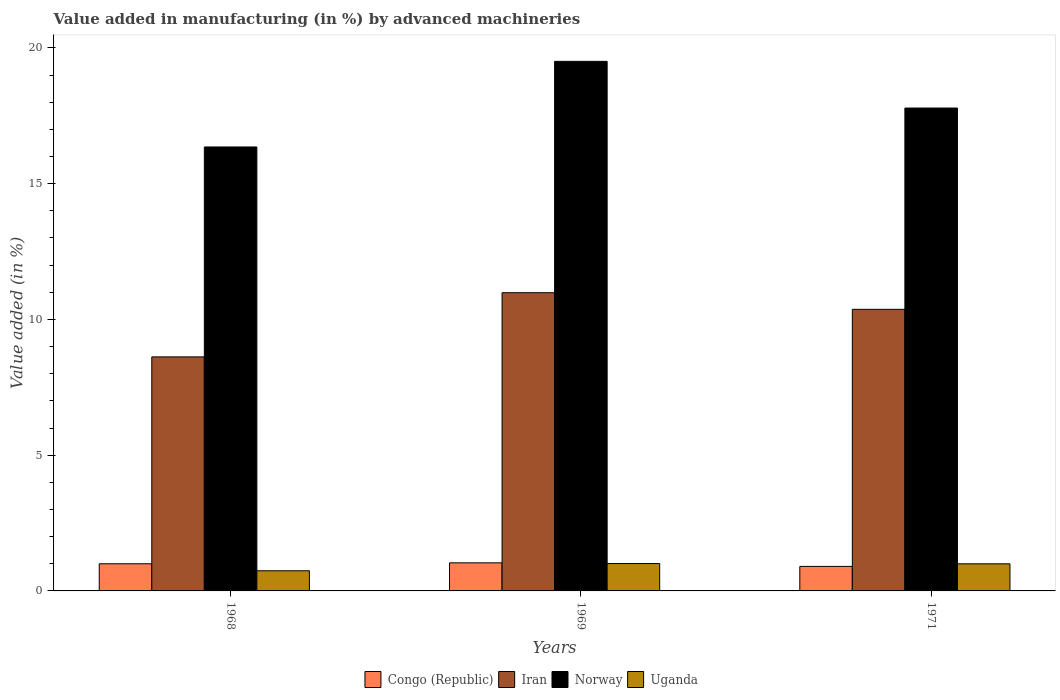Are the number of bars per tick equal to the number of legend labels?
Offer a terse response. Yes. Are the number of bars on each tick of the X-axis equal?
Offer a very short reply. Yes. How many bars are there on the 2nd tick from the left?
Your answer should be compact. 4. How many bars are there on the 2nd tick from the right?
Provide a short and direct response. 4. What is the label of the 2nd group of bars from the left?
Provide a short and direct response. 1969. In how many cases, is the number of bars for a given year not equal to the number of legend labels?
Offer a very short reply. 0. What is the percentage of value added in manufacturing by advanced machineries in Uganda in 1968?
Ensure brevity in your answer.  0.74. Across all years, what is the maximum percentage of value added in manufacturing by advanced machineries in Iran?
Your response must be concise. 10.98. Across all years, what is the minimum percentage of value added in manufacturing by advanced machineries in Norway?
Offer a terse response. 16.35. In which year was the percentage of value added in manufacturing by advanced machineries in Iran maximum?
Give a very brief answer. 1969. In which year was the percentage of value added in manufacturing by advanced machineries in Iran minimum?
Your answer should be very brief. 1968. What is the total percentage of value added in manufacturing by advanced machineries in Iran in the graph?
Keep it short and to the point. 29.97. What is the difference between the percentage of value added in manufacturing by advanced machineries in Uganda in 1968 and that in 1971?
Keep it short and to the point. -0.26. What is the difference between the percentage of value added in manufacturing by advanced machineries in Norway in 1969 and the percentage of value added in manufacturing by advanced machineries in Iran in 1971?
Give a very brief answer. 9.13. What is the average percentage of value added in manufacturing by advanced machineries in Norway per year?
Provide a short and direct response. 17.88. In the year 1968, what is the difference between the percentage of value added in manufacturing by advanced machineries in Uganda and percentage of value added in manufacturing by advanced machineries in Iran?
Offer a terse response. -7.88. In how many years, is the percentage of value added in manufacturing by advanced machineries in Uganda greater than 4 %?
Provide a succinct answer. 0. What is the ratio of the percentage of value added in manufacturing by advanced machineries in Uganda in 1968 to that in 1969?
Your answer should be very brief. 0.74. Is the difference between the percentage of value added in manufacturing by advanced machineries in Uganda in 1968 and 1971 greater than the difference between the percentage of value added in manufacturing by advanced machineries in Iran in 1968 and 1971?
Your response must be concise. Yes. What is the difference between the highest and the second highest percentage of value added in manufacturing by advanced machineries in Norway?
Your answer should be compact. 1.72. What is the difference between the highest and the lowest percentage of value added in manufacturing by advanced machineries in Uganda?
Provide a succinct answer. 0.27. In how many years, is the percentage of value added in manufacturing by advanced machineries in Uganda greater than the average percentage of value added in manufacturing by advanced machineries in Uganda taken over all years?
Keep it short and to the point. 2. Is it the case that in every year, the sum of the percentage of value added in manufacturing by advanced machineries in Norway and percentage of value added in manufacturing by advanced machineries in Congo (Republic) is greater than the sum of percentage of value added in manufacturing by advanced machineries in Uganda and percentage of value added in manufacturing by advanced machineries in Iran?
Make the answer very short. No. What does the 4th bar from the right in 1968 represents?
Make the answer very short. Congo (Republic). How many bars are there?
Give a very brief answer. 12. Are the values on the major ticks of Y-axis written in scientific E-notation?
Give a very brief answer. No. What is the title of the graph?
Offer a terse response. Value added in manufacturing (in %) by advanced machineries. Does "Pakistan" appear as one of the legend labels in the graph?
Your answer should be very brief. No. What is the label or title of the X-axis?
Give a very brief answer. Years. What is the label or title of the Y-axis?
Offer a very short reply. Value added (in %). What is the Value added (in %) of Congo (Republic) in 1968?
Your response must be concise. 1. What is the Value added (in %) in Iran in 1968?
Your answer should be compact. 8.62. What is the Value added (in %) in Norway in 1968?
Provide a short and direct response. 16.35. What is the Value added (in %) in Uganda in 1968?
Your answer should be compact. 0.74. What is the Value added (in %) of Congo (Republic) in 1969?
Your response must be concise. 1.03. What is the Value added (in %) of Iran in 1969?
Make the answer very short. 10.98. What is the Value added (in %) in Norway in 1969?
Your response must be concise. 19.5. What is the Value added (in %) in Uganda in 1969?
Your response must be concise. 1.01. What is the Value added (in %) in Congo (Republic) in 1971?
Provide a succinct answer. 0.9. What is the Value added (in %) in Iran in 1971?
Provide a succinct answer. 10.37. What is the Value added (in %) of Norway in 1971?
Offer a very short reply. 17.79. What is the Value added (in %) of Uganda in 1971?
Provide a short and direct response. 1. Across all years, what is the maximum Value added (in %) of Congo (Republic)?
Make the answer very short. 1.03. Across all years, what is the maximum Value added (in %) in Iran?
Offer a very short reply. 10.98. Across all years, what is the maximum Value added (in %) in Norway?
Offer a terse response. 19.5. Across all years, what is the maximum Value added (in %) in Uganda?
Provide a short and direct response. 1.01. Across all years, what is the minimum Value added (in %) of Congo (Republic)?
Ensure brevity in your answer.  0.9. Across all years, what is the minimum Value added (in %) in Iran?
Make the answer very short. 8.62. Across all years, what is the minimum Value added (in %) in Norway?
Ensure brevity in your answer.  16.35. Across all years, what is the minimum Value added (in %) of Uganda?
Provide a short and direct response. 0.74. What is the total Value added (in %) of Congo (Republic) in the graph?
Keep it short and to the point. 2.94. What is the total Value added (in %) of Iran in the graph?
Your response must be concise. 29.97. What is the total Value added (in %) of Norway in the graph?
Make the answer very short. 53.64. What is the total Value added (in %) of Uganda in the graph?
Provide a short and direct response. 2.75. What is the difference between the Value added (in %) in Congo (Republic) in 1968 and that in 1969?
Your answer should be compact. -0.03. What is the difference between the Value added (in %) of Iran in 1968 and that in 1969?
Your answer should be very brief. -2.36. What is the difference between the Value added (in %) in Norway in 1968 and that in 1969?
Your response must be concise. -3.15. What is the difference between the Value added (in %) of Uganda in 1968 and that in 1969?
Provide a succinct answer. -0.27. What is the difference between the Value added (in %) of Congo (Republic) in 1968 and that in 1971?
Keep it short and to the point. 0.1. What is the difference between the Value added (in %) of Iran in 1968 and that in 1971?
Your answer should be very brief. -1.75. What is the difference between the Value added (in %) of Norway in 1968 and that in 1971?
Your answer should be very brief. -1.43. What is the difference between the Value added (in %) in Uganda in 1968 and that in 1971?
Your answer should be compact. -0.26. What is the difference between the Value added (in %) of Congo (Republic) in 1969 and that in 1971?
Ensure brevity in your answer.  0.13. What is the difference between the Value added (in %) of Iran in 1969 and that in 1971?
Provide a short and direct response. 0.61. What is the difference between the Value added (in %) of Norway in 1969 and that in 1971?
Your answer should be very brief. 1.72. What is the difference between the Value added (in %) of Uganda in 1969 and that in 1971?
Provide a succinct answer. 0.01. What is the difference between the Value added (in %) of Congo (Republic) in 1968 and the Value added (in %) of Iran in 1969?
Provide a short and direct response. -9.98. What is the difference between the Value added (in %) of Congo (Republic) in 1968 and the Value added (in %) of Norway in 1969?
Offer a very short reply. -18.5. What is the difference between the Value added (in %) in Congo (Republic) in 1968 and the Value added (in %) in Uganda in 1969?
Keep it short and to the point. -0.01. What is the difference between the Value added (in %) in Iran in 1968 and the Value added (in %) in Norway in 1969?
Give a very brief answer. -10.88. What is the difference between the Value added (in %) of Iran in 1968 and the Value added (in %) of Uganda in 1969?
Your response must be concise. 7.61. What is the difference between the Value added (in %) in Norway in 1968 and the Value added (in %) in Uganda in 1969?
Provide a short and direct response. 15.34. What is the difference between the Value added (in %) in Congo (Republic) in 1968 and the Value added (in %) in Iran in 1971?
Make the answer very short. -9.37. What is the difference between the Value added (in %) in Congo (Republic) in 1968 and the Value added (in %) in Norway in 1971?
Make the answer very short. -16.79. What is the difference between the Value added (in %) in Congo (Republic) in 1968 and the Value added (in %) in Uganda in 1971?
Provide a succinct answer. 0. What is the difference between the Value added (in %) of Iran in 1968 and the Value added (in %) of Norway in 1971?
Your response must be concise. -9.17. What is the difference between the Value added (in %) in Iran in 1968 and the Value added (in %) in Uganda in 1971?
Make the answer very short. 7.62. What is the difference between the Value added (in %) in Norway in 1968 and the Value added (in %) in Uganda in 1971?
Ensure brevity in your answer.  15.35. What is the difference between the Value added (in %) in Congo (Republic) in 1969 and the Value added (in %) in Iran in 1971?
Ensure brevity in your answer.  -9.34. What is the difference between the Value added (in %) of Congo (Republic) in 1969 and the Value added (in %) of Norway in 1971?
Offer a terse response. -16.75. What is the difference between the Value added (in %) of Congo (Republic) in 1969 and the Value added (in %) of Uganda in 1971?
Keep it short and to the point. 0.04. What is the difference between the Value added (in %) of Iran in 1969 and the Value added (in %) of Norway in 1971?
Offer a terse response. -6.8. What is the difference between the Value added (in %) of Iran in 1969 and the Value added (in %) of Uganda in 1971?
Offer a terse response. 9.98. What is the difference between the Value added (in %) of Norway in 1969 and the Value added (in %) of Uganda in 1971?
Your answer should be very brief. 18.51. What is the average Value added (in %) of Congo (Republic) per year?
Ensure brevity in your answer.  0.98. What is the average Value added (in %) in Iran per year?
Make the answer very short. 9.99. What is the average Value added (in %) of Norway per year?
Keep it short and to the point. 17.88. What is the average Value added (in %) in Uganda per year?
Provide a short and direct response. 0.92. In the year 1968, what is the difference between the Value added (in %) in Congo (Republic) and Value added (in %) in Iran?
Keep it short and to the point. -7.62. In the year 1968, what is the difference between the Value added (in %) in Congo (Republic) and Value added (in %) in Norway?
Make the answer very short. -15.35. In the year 1968, what is the difference between the Value added (in %) in Congo (Republic) and Value added (in %) in Uganda?
Your answer should be compact. 0.26. In the year 1968, what is the difference between the Value added (in %) in Iran and Value added (in %) in Norway?
Give a very brief answer. -7.73. In the year 1968, what is the difference between the Value added (in %) of Iran and Value added (in %) of Uganda?
Offer a terse response. 7.88. In the year 1968, what is the difference between the Value added (in %) of Norway and Value added (in %) of Uganda?
Your answer should be very brief. 15.61. In the year 1969, what is the difference between the Value added (in %) in Congo (Republic) and Value added (in %) in Iran?
Offer a very short reply. -9.95. In the year 1969, what is the difference between the Value added (in %) of Congo (Republic) and Value added (in %) of Norway?
Offer a very short reply. -18.47. In the year 1969, what is the difference between the Value added (in %) of Congo (Republic) and Value added (in %) of Uganda?
Make the answer very short. 0.03. In the year 1969, what is the difference between the Value added (in %) in Iran and Value added (in %) in Norway?
Offer a very short reply. -8.52. In the year 1969, what is the difference between the Value added (in %) of Iran and Value added (in %) of Uganda?
Ensure brevity in your answer.  9.97. In the year 1969, what is the difference between the Value added (in %) of Norway and Value added (in %) of Uganda?
Provide a succinct answer. 18.5. In the year 1971, what is the difference between the Value added (in %) in Congo (Republic) and Value added (in %) in Iran?
Ensure brevity in your answer.  -9.47. In the year 1971, what is the difference between the Value added (in %) in Congo (Republic) and Value added (in %) in Norway?
Your response must be concise. -16.88. In the year 1971, what is the difference between the Value added (in %) in Congo (Republic) and Value added (in %) in Uganda?
Your answer should be compact. -0.09. In the year 1971, what is the difference between the Value added (in %) in Iran and Value added (in %) in Norway?
Provide a short and direct response. -7.41. In the year 1971, what is the difference between the Value added (in %) of Iran and Value added (in %) of Uganda?
Offer a very short reply. 9.37. In the year 1971, what is the difference between the Value added (in %) of Norway and Value added (in %) of Uganda?
Provide a short and direct response. 16.79. What is the ratio of the Value added (in %) in Congo (Republic) in 1968 to that in 1969?
Offer a terse response. 0.97. What is the ratio of the Value added (in %) in Iran in 1968 to that in 1969?
Provide a succinct answer. 0.78. What is the ratio of the Value added (in %) of Norway in 1968 to that in 1969?
Offer a terse response. 0.84. What is the ratio of the Value added (in %) of Uganda in 1968 to that in 1969?
Ensure brevity in your answer.  0.74. What is the ratio of the Value added (in %) in Congo (Republic) in 1968 to that in 1971?
Make the answer very short. 1.11. What is the ratio of the Value added (in %) of Iran in 1968 to that in 1971?
Make the answer very short. 0.83. What is the ratio of the Value added (in %) of Norway in 1968 to that in 1971?
Keep it short and to the point. 0.92. What is the ratio of the Value added (in %) in Uganda in 1968 to that in 1971?
Your response must be concise. 0.74. What is the ratio of the Value added (in %) of Congo (Republic) in 1969 to that in 1971?
Ensure brevity in your answer.  1.15. What is the ratio of the Value added (in %) in Iran in 1969 to that in 1971?
Your answer should be compact. 1.06. What is the ratio of the Value added (in %) in Norway in 1969 to that in 1971?
Your answer should be very brief. 1.1. What is the ratio of the Value added (in %) in Uganda in 1969 to that in 1971?
Ensure brevity in your answer.  1.01. What is the difference between the highest and the second highest Value added (in %) of Congo (Republic)?
Provide a short and direct response. 0.03. What is the difference between the highest and the second highest Value added (in %) in Iran?
Offer a very short reply. 0.61. What is the difference between the highest and the second highest Value added (in %) of Norway?
Give a very brief answer. 1.72. What is the difference between the highest and the second highest Value added (in %) in Uganda?
Your response must be concise. 0.01. What is the difference between the highest and the lowest Value added (in %) in Congo (Republic)?
Provide a succinct answer. 0.13. What is the difference between the highest and the lowest Value added (in %) in Iran?
Give a very brief answer. 2.36. What is the difference between the highest and the lowest Value added (in %) of Norway?
Your answer should be very brief. 3.15. What is the difference between the highest and the lowest Value added (in %) in Uganda?
Keep it short and to the point. 0.27. 